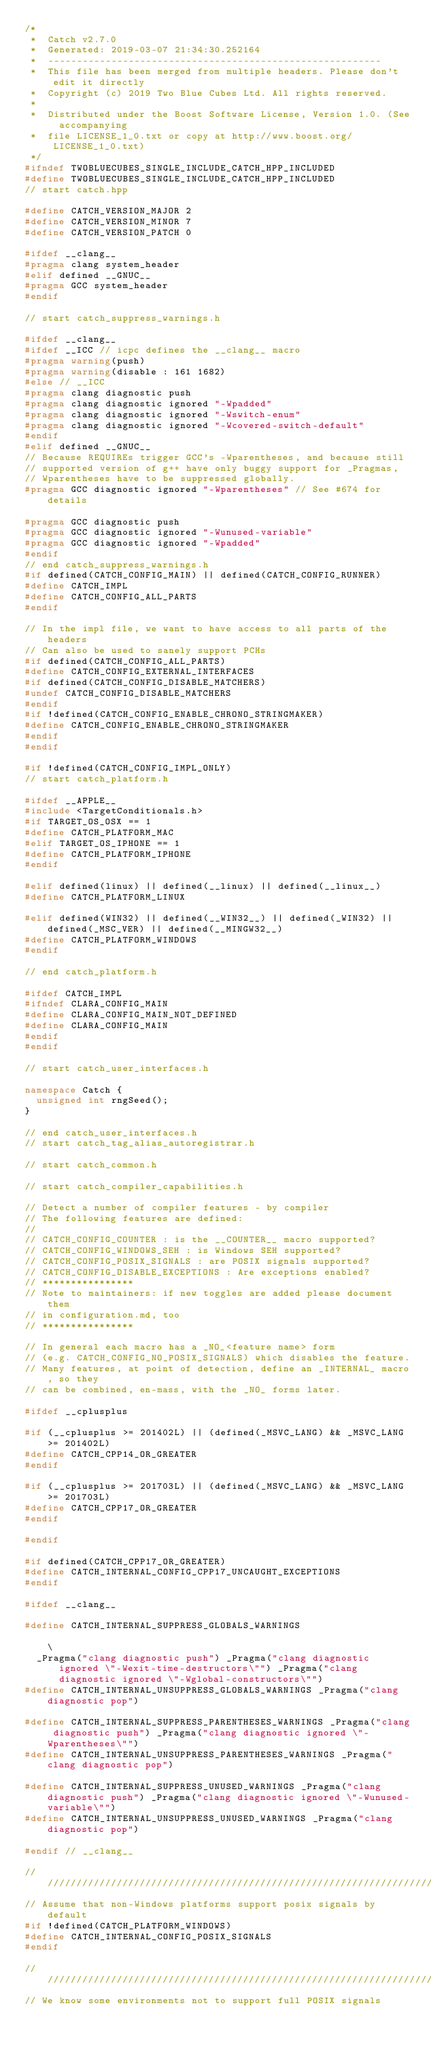<code> <loc_0><loc_0><loc_500><loc_500><_C++_>/*
 *  Catch v2.7.0
 *  Generated: 2019-03-07 21:34:30.252164
 *  ----------------------------------------------------------
 *  This file has been merged from multiple headers. Please don't edit it directly
 *  Copyright (c) 2019 Two Blue Cubes Ltd. All rights reserved.
 *
 *  Distributed under the Boost Software License, Version 1.0. (See accompanying
 *  file LICENSE_1_0.txt or copy at http://www.boost.org/LICENSE_1_0.txt)
 */
#ifndef TWOBLUECUBES_SINGLE_INCLUDE_CATCH_HPP_INCLUDED
#define TWOBLUECUBES_SINGLE_INCLUDE_CATCH_HPP_INCLUDED
// start catch.hpp

#define CATCH_VERSION_MAJOR 2
#define CATCH_VERSION_MINOR 7
#define CATCH_VERSION_PATCH 0

#ifdef __clang__
#pragma clang system_header
#elif defined __GNUC__
#pragma GCC system_header
#endif

// start catch_suppress_warnings.h

#ifdef __clang__
#ifdef __ICC // icpc defines the __clang__ macro
#pragma warning(push)
#pragma warning(disable : 161 1682)
#else // __ICC
#pragma clang diagnostic push
#pragma clang diagnostic ignored "-Wpadded"
#pragma clang diagnostic ignored "-Wswitch-enum"
#pragma clang diagnostic ignored "-Wcovered-switch-default"
#endif
#elif defined __GNUC__
// Because REQUIREs trigger GCC's -Wparentheses, and because still
// supported version of g++ have only buggy support for _Pragmas,
// Wparentheses have to be suppressed globally.
#pragma GCC diagnostic ignored "-Wparentheses" // See #674 for details

#pragma GCC diagnostic push
#pragma GCC diagnostic ignored "-Wunused-variable"
#pragma GCC diagnostic ignored "-Wpadded"
#endif
// end catch_suppress_warnings.h
#if defined(CATCH_CONFIG_MAIN) || defined(CATCH_CONFIG_RUNNER)
#define CATCH_IMPL
#define CATCH_CONFIG_ALL_PARTS
#endif

// In the impl file, we want to have access to all parts of the headers
// Can also be used to sanely support PCHs
#if defined(CATCH_CONFIG_ALL_PARTS)
#define CATCH_CONFIG_EXTERNAL_INTERFACES
#if defined(CATCH_CONFIG_DISABLE_MATCHERS)
#undef CATCH_CONFIG_DISABLE_MATCHERS
#endif
#if !defined(CATCH_CONFIG_ENABLE_CHRONO_STRINGMAKER)
#define CATCH_CONFIG_ENABLE_CHRONO_STRINGMAKER
#endif
#endif

#if !defined(CATCH_CONFIG_IMPL_ONLY)
// start catch_platform.h

#ifdef __APPLE__
#include <TargetConditionals.h>
#if TARGET_OS_OSX == 1
#define CATCH_PLATFORM_MAC
#elif TARGET_OS_IPHONE == 1
#define CATCH_PLATFORM_IPHONE
#endif

#elif defined(linux) || defined(__linux) || defined(__linux__)
#define CATCH_PLATFORM_LINUX

#elif defined(WIN32) || defined(__WIN32__) || defined(_WIN32) || defined(_MSC_VER) || defined(__MINGW32__)
#define CATCH_PLATFORM_WINDOWS
#endif

// end catch_platform.h

#ifdef CATCH_IMPL
#ifndef CLARA_CONFIG_MAIN
#define CLARA_CONFIG_MAIN_NOT_DEFINED
#define CLARA_CONFIG_MAIN
#endif
#endif

// start catch_user_interfaces.h

namespace Catch {
  unsigned int rngSeed();
}

// end catch_user_interfaces.h
// start catch_tag_alias_autoregistrar.h

// start catch_common.h

// start catch_compiler_capabilities.h

// Detect a number of compiler features - by compiler
// The following features are defined:
//
// CATCH_CONFIG_COUNTER : is the __COUNTER__ macro supported?
// CATCH_CONFIG_WINDOWS_SEH : is Windows SEH supported?
// CATCH_CONFIG_POSIX_SIGNALS : are POSIX signals supported?
// CATCH_CONFIG_DISABLE_EXCEPTIONS : Are exceptions enabled?
// ****************
// Note to maintainers: if new toggles are added please document them
// in configuration.md, too
// ****************

// In general each macro has a _NO_<feature name> form
// (e.g. CATCH_CONFIG_NO_POSIX_SIGNALS) which disables the feature.
// Many features, at point of detection, define an _INTERNAL_ macro, so they
// can be combined, en-mass, with the _NO_ forms later.

#ifdef __cplusplus

#if (__cplusplus >= 201402L) || (defined(_MSVC_LANG) && _MSVC_LANG >= 201402L)
#define CATCH_CPP14_OR_GREATER
#endif

#if (__cplusplus >= 201703L) || (defined(_MSVC_LANG) && _MSVC_LANG >= 201703L)
#define CATCH_CPP17_OR_GREATER
#endif

#endif

#if defined(CATCH_CPP17_OR_GREATER)
#define CATCH_INTERNAL_CONFIG_CPP17_UNCAUGHT_EXCEPTIONS
#endif

#ifdef __clang__

#define CATCH_INTERNAL_SUPPRESS_GLOBALS_WARNINGS                                                                                                               \
  _Pragma("clang diagnostic push") _Pragma("clang diagnostic ignored \"-Wexit-time-destructors\"") _Pragma("clang diagnostic ignored \"-Wglobal-constructors\"")
#define CATCH_INTERNAL_UNSUPPRESS_GLOBALS_WARNINGS _Pragma("clang diagnostic pop")

#define CATCH_INTERNAL_SUPPRESS_PARENTHESES_WARNINGS _Pragma("clang diagnostic push") _Pragma("clang diagnostic ignored \"-Wparentheses\"")
#define CATCH_INTERNAL_UNSUPPRESS_PARENTHESES_WARNINGS _Pragma("clang diagnostic pop")

#define CATCH_INTERNAL_SUPPRESS_UNUSED_WARNINGS _Pragma("clang diagnostic push") _Pragma("clang diagnostic ignored \"-Wunused-variable\"")
#define CATCH_INTERNAL_UNSUPPRESS_UNUSED_WARNINGS _Pragma("clang diagnostic pop")

#endif // __clang__

////////////////////////////////////////////////////////////////////////////////
// Assume that non-Windows platforms support posix signals by default
#if !defined(CATCH_PLATFORM_WINDOWS)
#define CATCH_INTERNAL_CONFIG_POSIX_SIGNALS
#endif

////////////////////////////////////////////////////////////////////////////////
// We know some environments not to support full POSIX signals</code> 